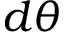Convert formula to latex. <formula><loc_0><loc_0><loc_500><loc_500>d \theta</formula> 